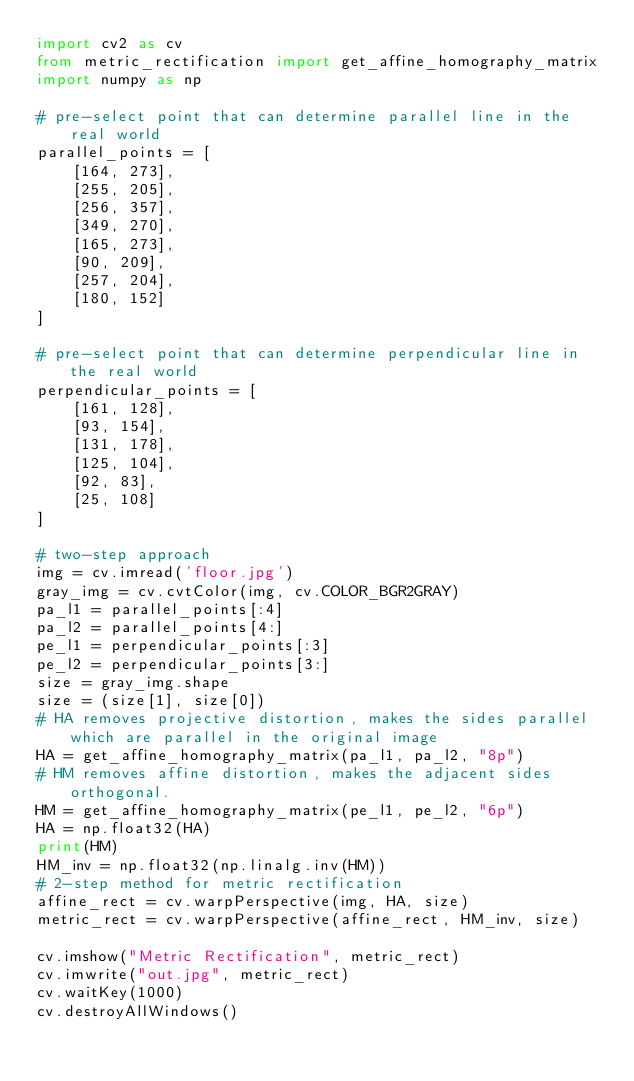Convert code to text. <code><loc_0><loc_0><loc_500><loc_500><_Python_>import cv2 as cv
from metric_rectification import get_affine_homography_matrix
import numpy as np

# pre-select point that can determine parallel line in the real world
parallel_points = [
    [164, 273],
    [255, 205],
    [256, 357],
    [349, 270],
    [165, 273],
    [90, 209],
    [257, 204],
    [180, 152]
]

# pre-select point that can determine perpendicular line in the real world
perpendicular_points = [
    [161, 128],
    [93, 154],
    [131, 178],
    [125, 104],
    [92, 83],
    [25, 108]
]

# two-step approach
img = cv.imread('floor.jpg')
gray_img = cv.cvtColor(img, cv.COLOR_BGR2GRAY)
pa_l1 = parallel_points[:4]
pa_l2 = parallel_points[4:]
pe_l1 = perpendicular_points[:3]
pe_l2 = perpendicular_points[3:]
size = gray_img.shape
size = (size[1], size[0])
# HA removes projective distortion, makes the sides parallel which are parallel in the original image
HA = get_affine_homography_matrix(pa_l1, pa_l2, "8p")
# HM removes affine distortion, makes the adjacent sides orthogonal.
HM = get_affine_homography_matrix(pe_l1, pe_l2, "6p")
HA = np.float32(HA)
print(HM)
HM_inv = np.float32(np.linalg.inv(HM))
# 2-step method for metric rectification
affine_rect = cv.warpPerspective(img, HA, size)
metric_rect = cv.warpPerspective(affine_rect, HM_inv, size)

cv.imshow("Metric Rectification", metric_rect)
cv.imwrite("out.jpg", metric_rect)
cv.waitKey(1000)
cv.destroyAllWindows()

</code> 